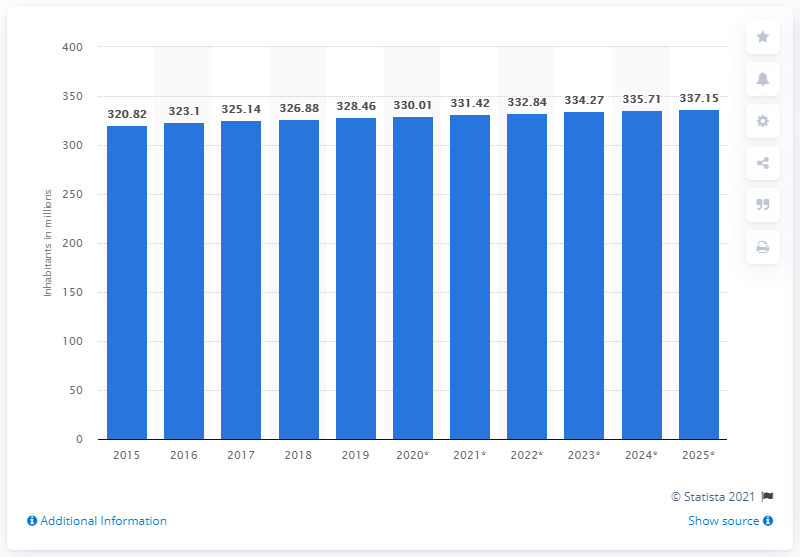Point out several critical features in this image. In 2019, the population of the United States was approximately 331.42 million. In the year 2015, it was estimated that the population of the United States was 328.46 million. 